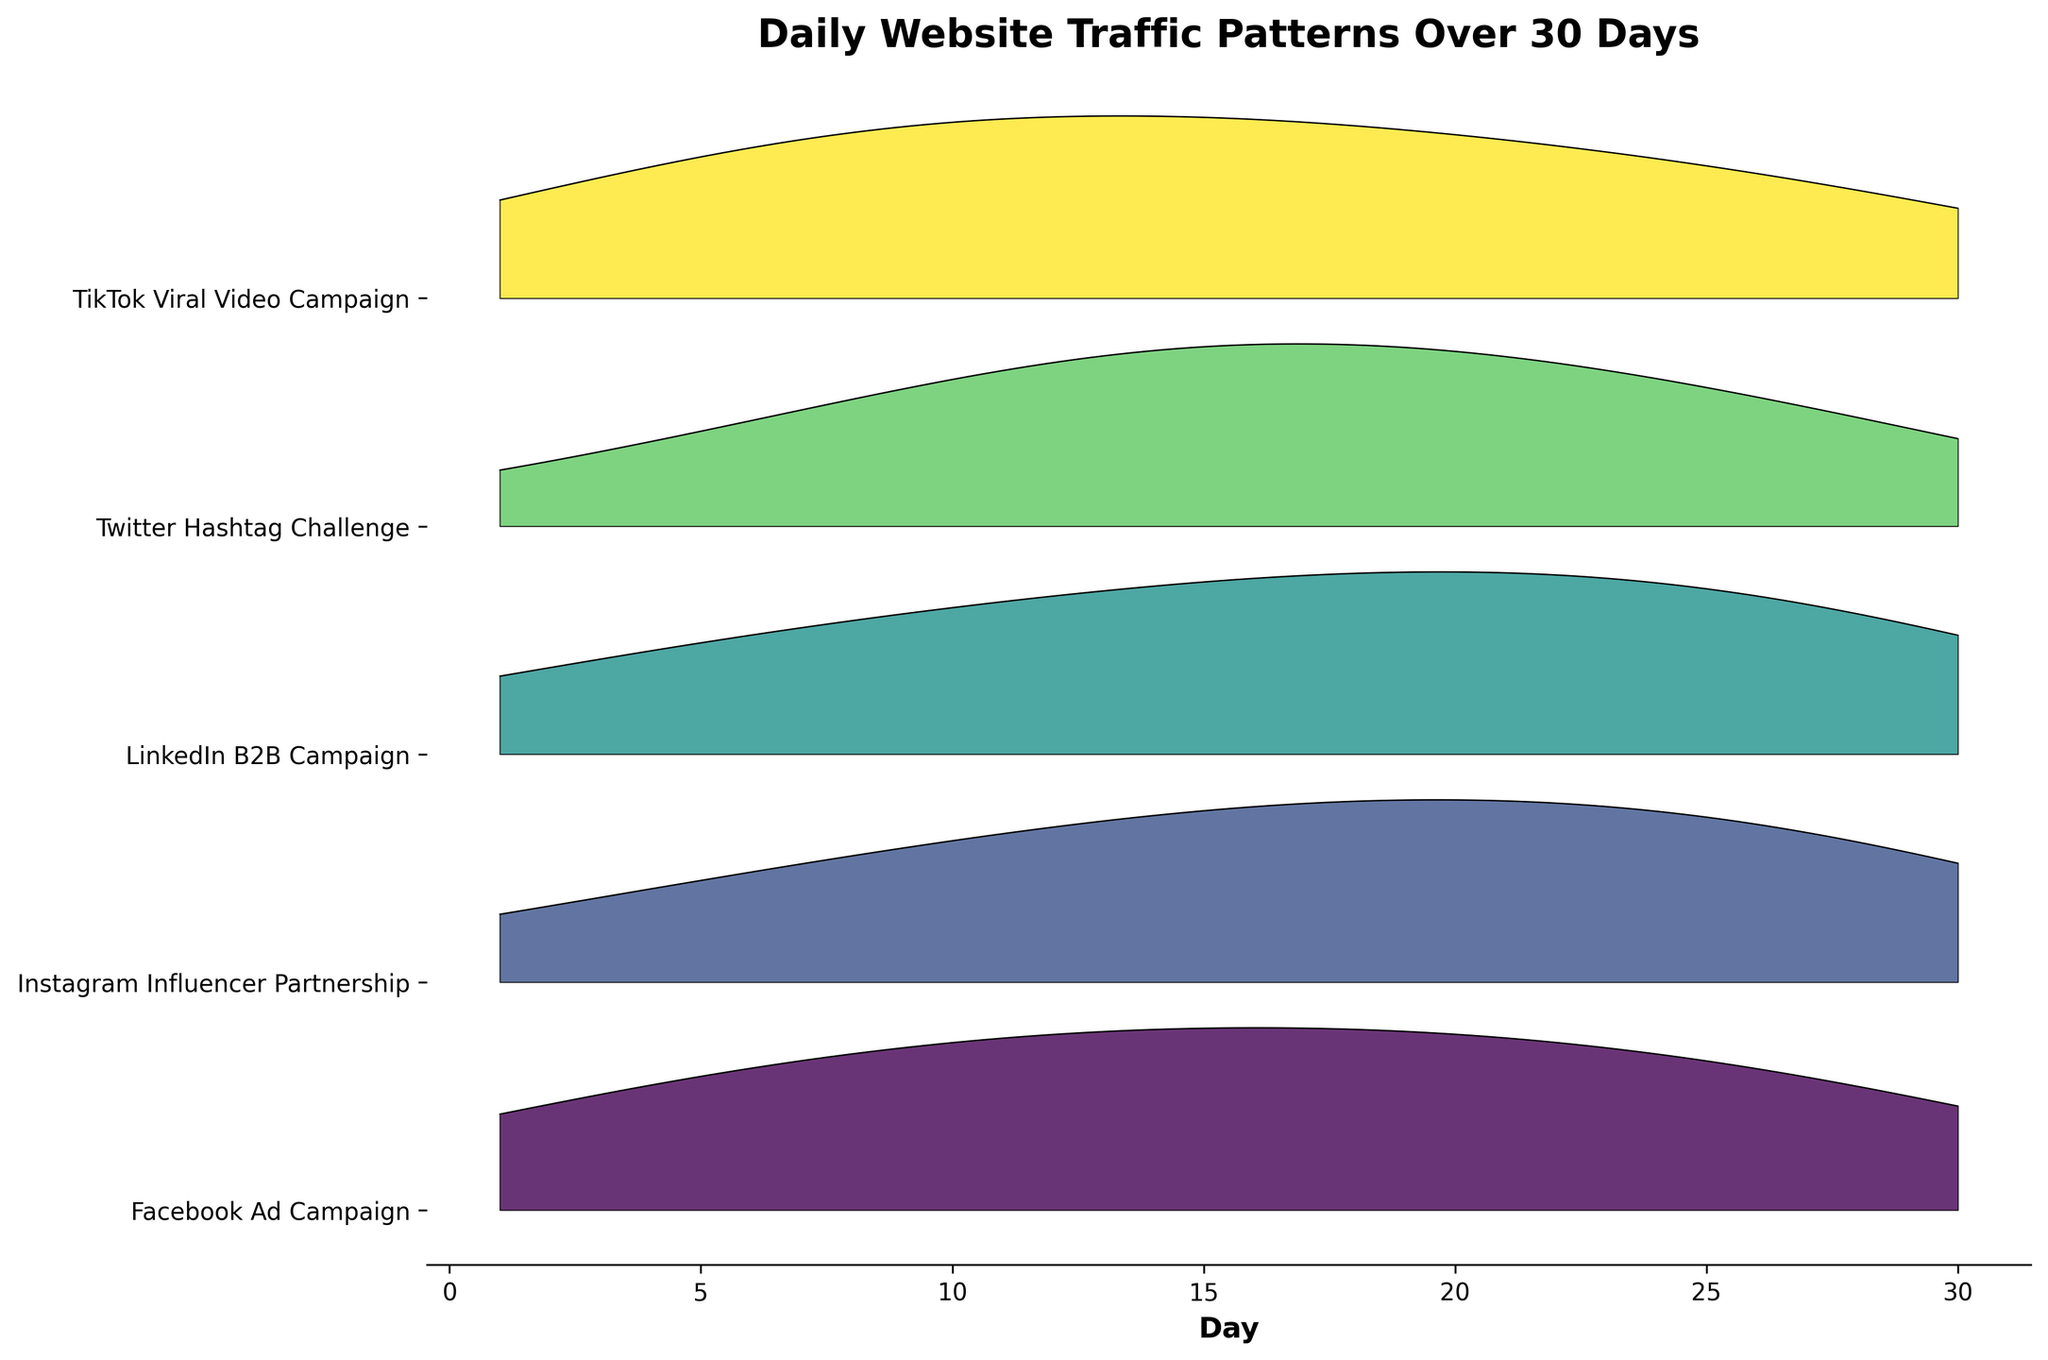What is the title of the figure? The title of the figure is generally written at the top of the figure.
Answer: Daily Website Traffic Patterns Over 30 Days How many social media campaigns are compared in the ridgeline plot? Counting the unique labels on the y-axis indicating different campaigns will determine the number of campaigns.
Answer: Five Which campaign had the highest peak in visitors? By examining the highest filled peak along the y-axis, you can identify which campaign it corresponds to.
Answer: TikTok Viral Video Campaign On which day does the Facebook Ad Campaign show a peak in visitors? Look for the highest filled area along the x-axis within the Facebook Ad Campaign row. Identify the corresponding day.
Answer: Day 15 Compare the visitor trend on Day 10 between the Instagram Influencer Partnership and Twitter Hashtag Challenge campaigns. Which one had more visitors? Examine and compare the height of the filled peaks at Day 10 for both campaigns.
Answer: Instagram Influencer Partnership What is the general trend of the LinkedIn B2B Campaign over the 30-day period? Observe the overall shape and progression of the ridgeline for LinkedIn B2B Campaign across the 30-day period.
Answer: Gradually increasing initially, then decreasing towards the end Which campaign shows the most consistent visitor pattern without sharp peaks? Identify the campaign which has the smoothest and most uniform peaks across the 30 days.
Answer: LinkedIn B2B Campaign What is the pattern of visitor changes for the TikTok Viral Video Campaign after Day 15? Look at the heights of the filled areas after Day 15 in the TikTok Viral Video Campaign row to observe the pattern.
Answer: Decreases steadily How does the visitors count for the Instagram Influencer Partnership change from Day 20 to Day 25? Examine the ridge heights for the Instagram Influencer Partnership between Days 20 and 25.
Answer: Decreases Among all the campaigns, which one shows a significant drop in visitors around Day 25? Identify the campaign with a noticeable decline in ridge height around Day 25.
Answer: Twitter Hashtag Challenge 